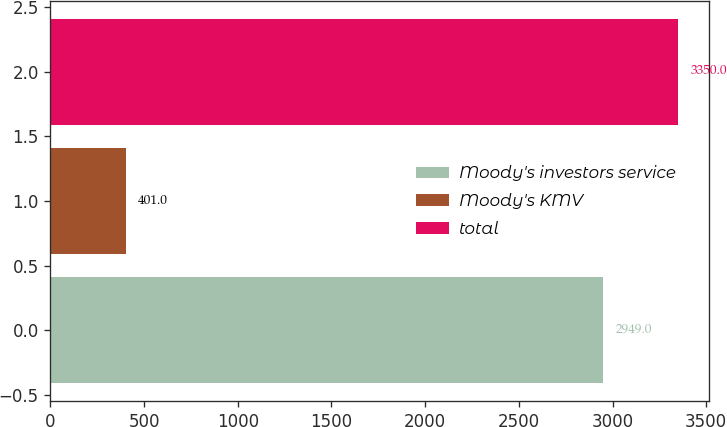<chart> <loc_0><loc_0><loc_500><loc_500><bar_chart><fcel>Moody's investors service<fcel>Moody's KMV<fcel>total<nl><fcel>2949<fcel>401<fcel>3350<nl></chart> 